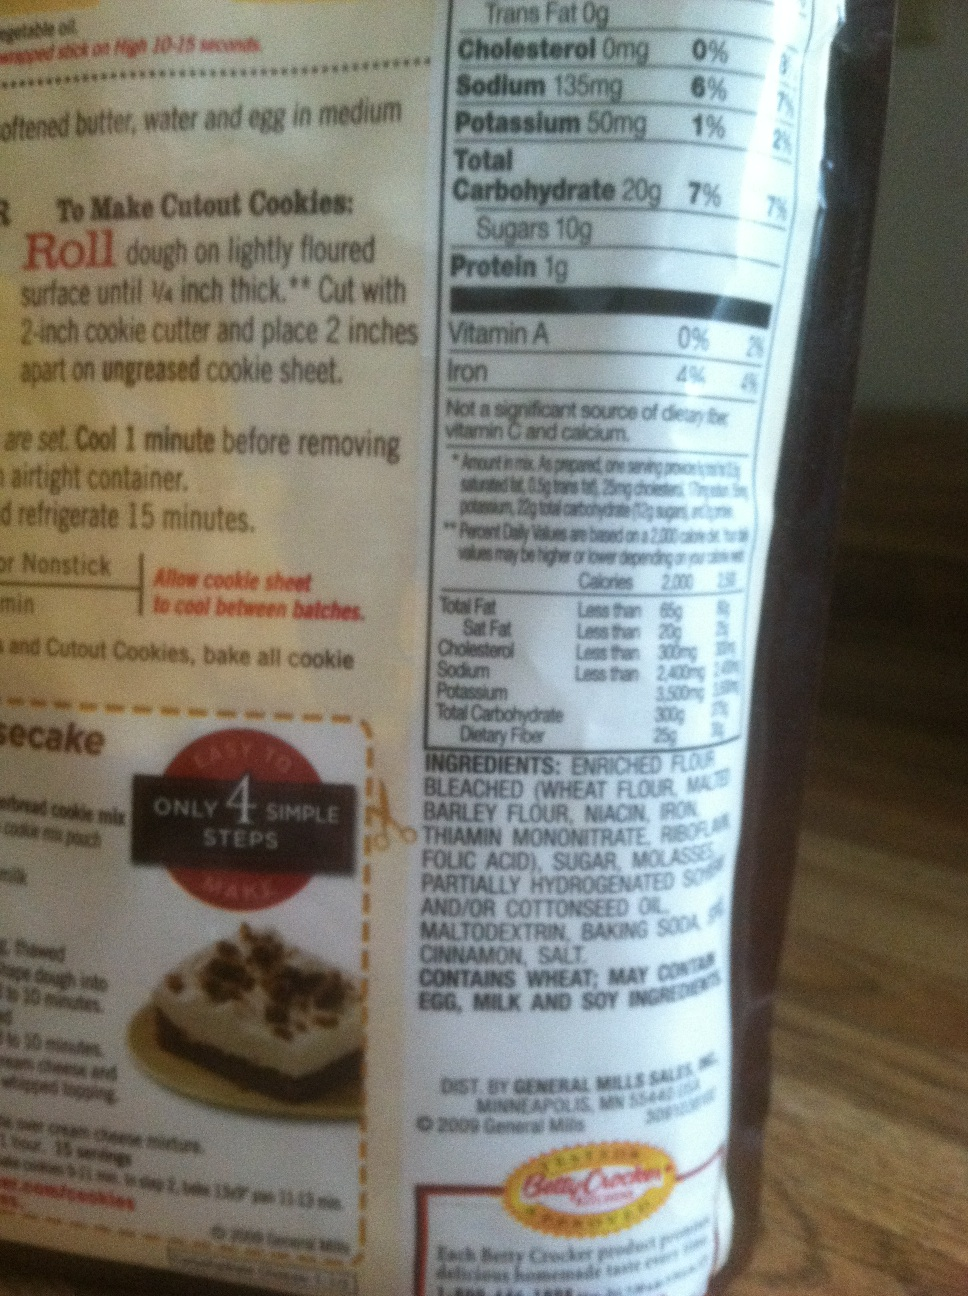If you could turn this bag into a magical recipe, what would it make and what powers would it grant? If this bag turned into a magical recipe, it would create 'Enchanting Cookies'. These cookies would grant anyone who eats them the ability to communicate with animals for 24 hours. Imagine having deep conversations with birds, getting advice from wise old trees, and understanding the secrets shared by the whispering winds! 